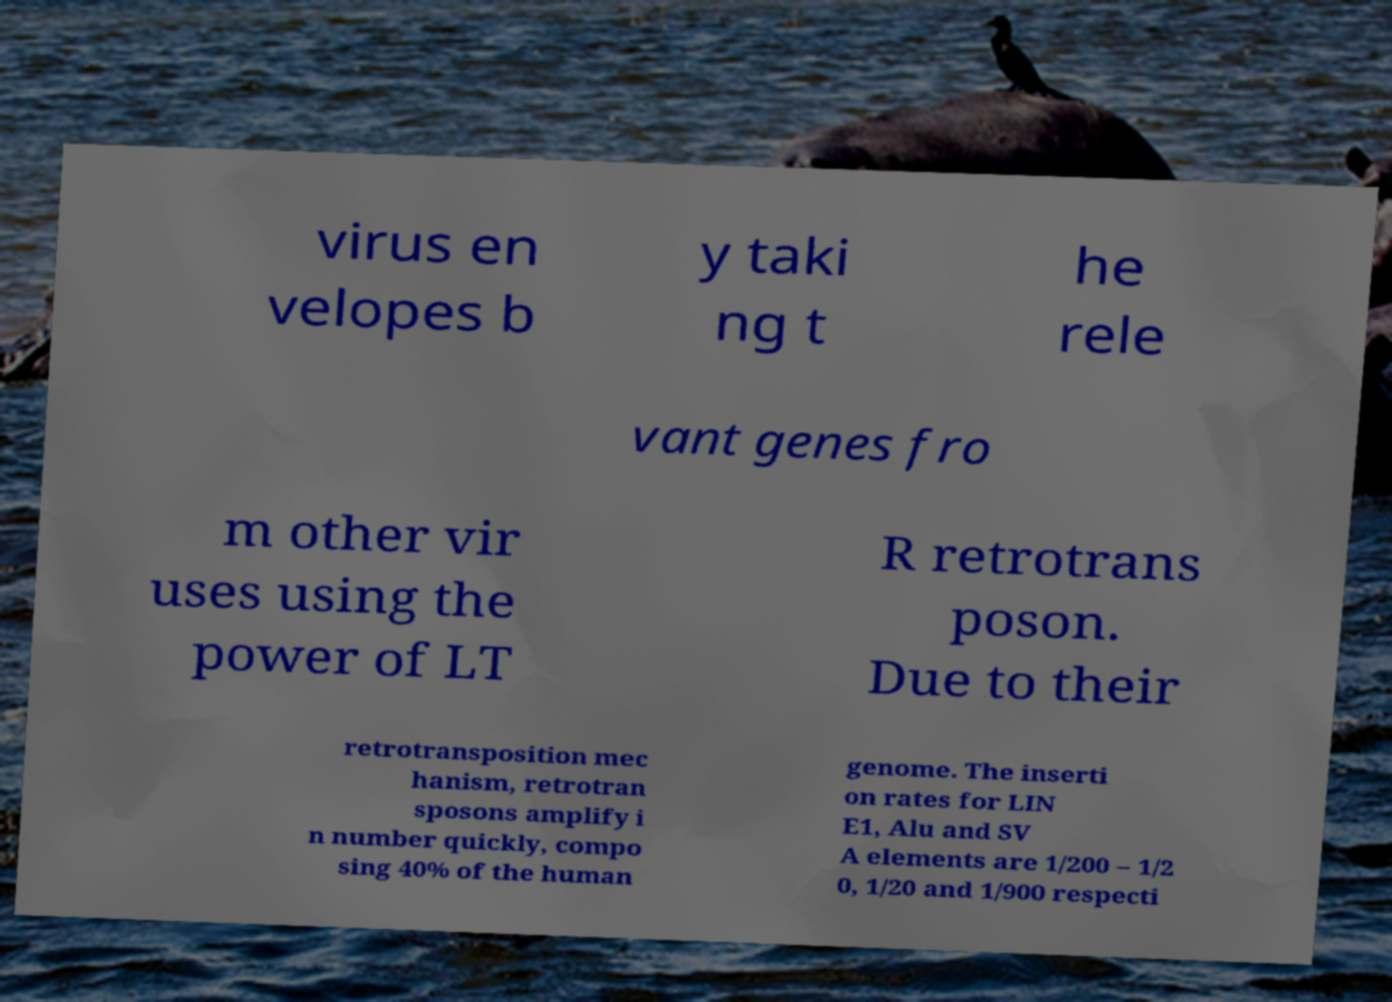Can you read and provide the text displayed in the image?This photo seems to have some interesting text. Can you extract and type it out for me? virus en velopes b y taki ng t he rele vant genes fro m other vir uses using the power of LT R retrotrans poson. Due to their retrotransposition mec hanism, retrotran sposons amplify i n number quickly, compo sing 40% of the human genome. The inserti on rates for LIN E1, Alu and SV A elements are 1/200 – 1/2 0, 1/20 and 1/900 respecti 